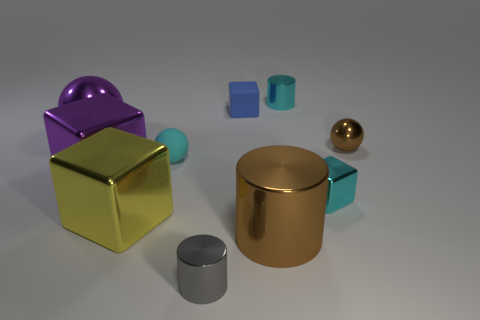Is the material of the big block that is in front of the purple cube the same as the large purple object on the right side of the large purple metal sphere?
Make the answer very short. Yes. How many cubes are there?
Keep it short and to the point. 4. What shape is the cyan shiny thing that is behind the large shiny ball?
Keep it short and to the point. Cylinder. How many other objects are there of the same size as the blue matte cube?
Your answer should be compact. 5. There is a large purple shiny thing in front of the big ball; does it have the same shape as the small rubber thing that is in front of the brown metallic ball?
Provide a succinct answer. No. How many tiny matte blocks are in front of the cyan block?
Make the answer very short. 0. There is a small cylinder behind the gray cylinder; what color is it?
Make the answer very short. Cyan. The other rubber thing that is the same shape as the large yellow thing is what color?
Ensure brevity in your answer.  Blue. Are there any other things of the same color as the rubber sphere?
Give a very brief answer. Yes. Is the number of tiny brown rubber objects greater than the number of large metallic blocks?
Make the answer very short. No. 